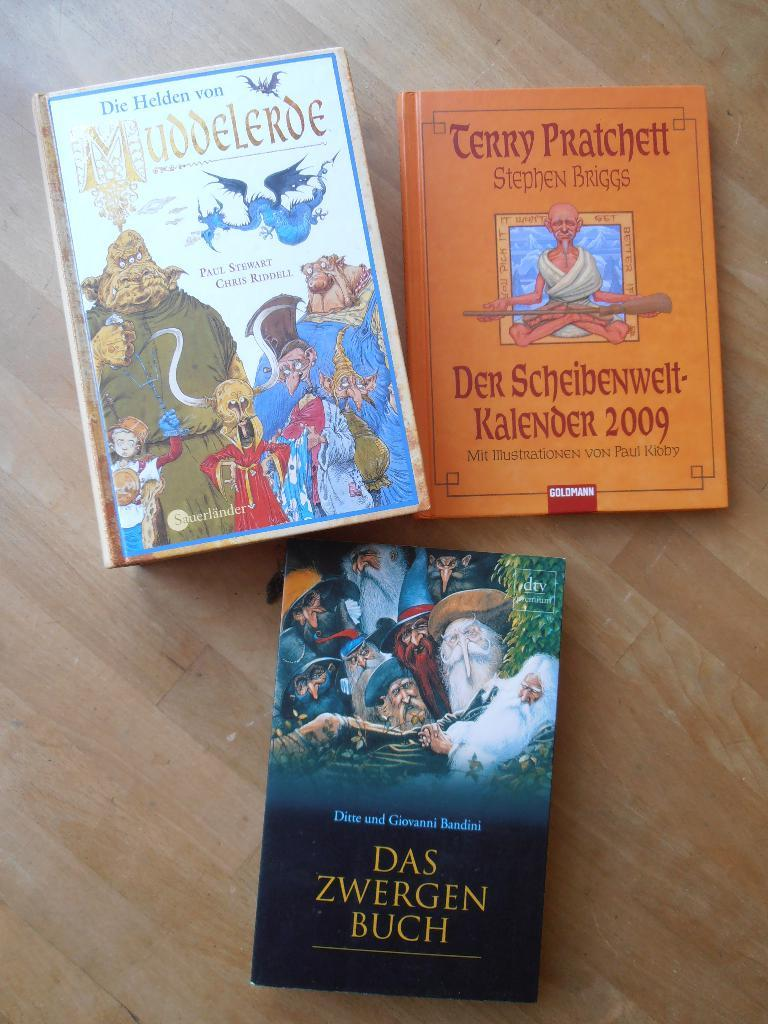<image>
Provide a brief description of the given image. The orange book is written by Stephen Briggs 